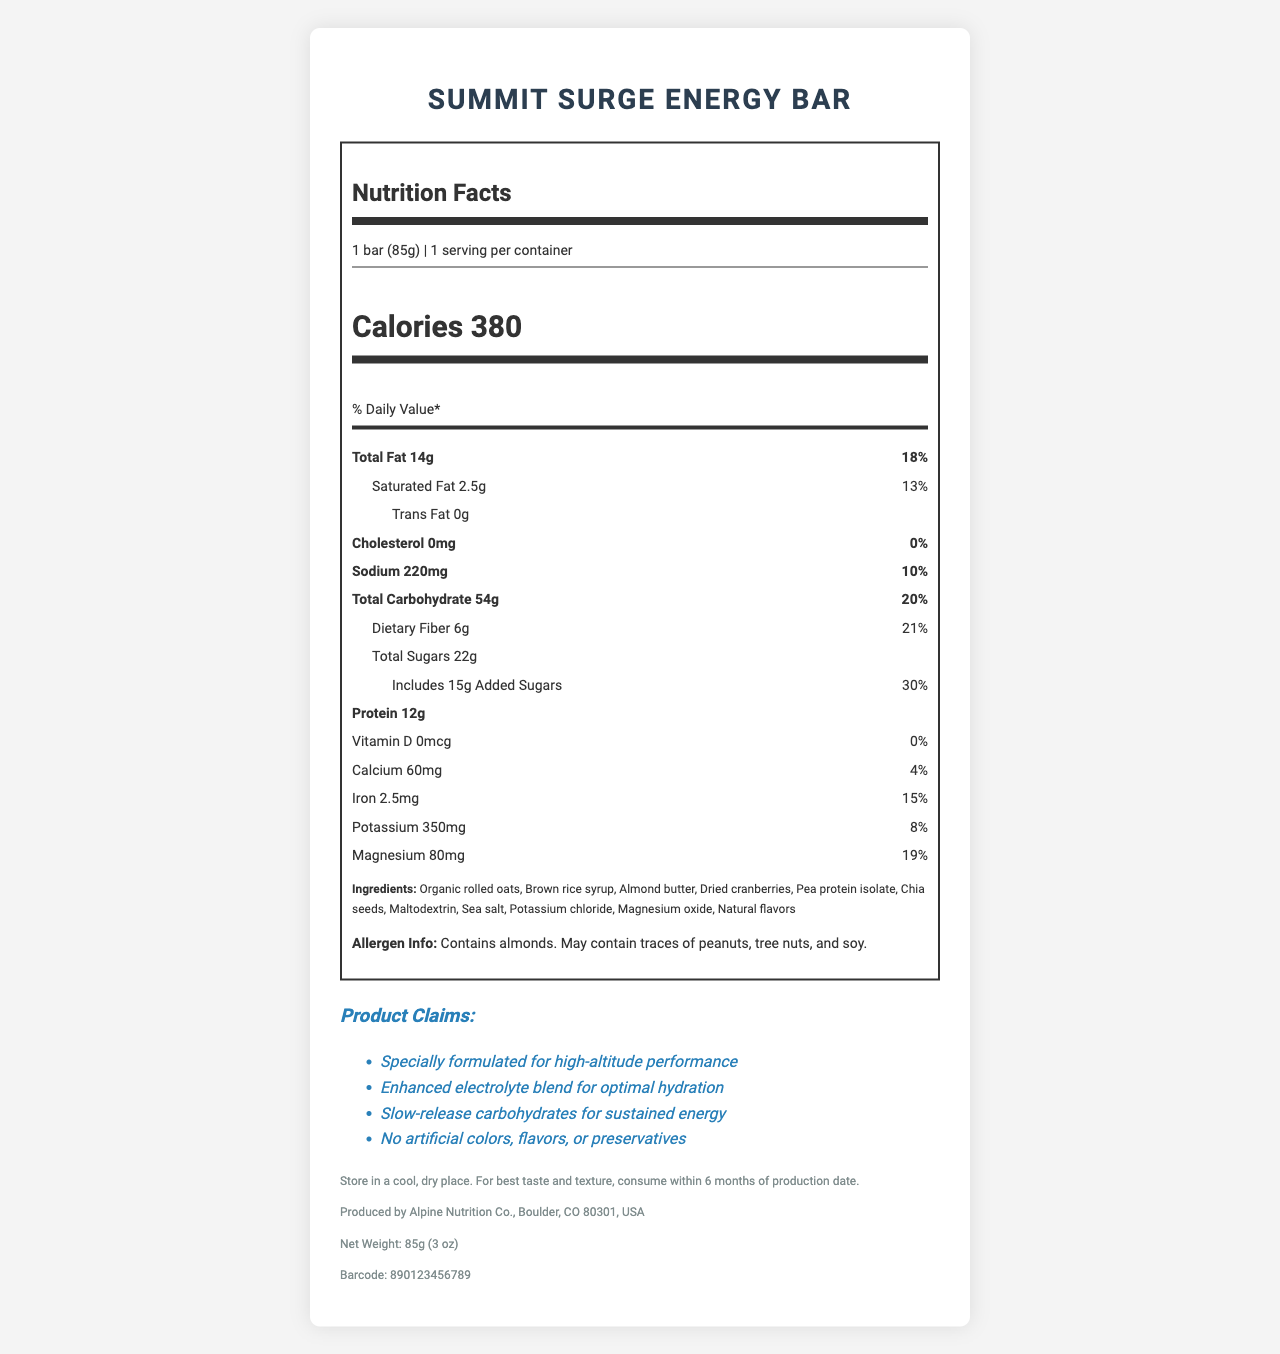What is the serving size of the Summit Surge Energy Bar? The serving size is stated explicitly as "1 bar (85g)" under the nutrition facts section.
Answer: 1 bar (85g) How many calories are in one serving of the Summit Surge Energy Bar? The document specifies "Calories 380" prominently under the nutrition facts.
Answer: 380 What percentage of the daily value of saturated fat does one bar provide? Under the saturated fat section, it lists "2.5g" and "13%".
Answer: 13% Which ingredient is listed first in the Summit Surge Energy Bar? The ingredients are listed in order of predominance, and organic rolled oats are the first ingredient mentioned.
Answer: Organic rolled oats How much added sugars does the Summit Surge Energy Bar contain? The document shows "Includes 15g Added Sugars" under the total sugars section.
Answer: 15g What are the total carbohydrates in one serving? A. 10g B. 20g C. 30g D. 54g The total carbohydrates are listed as "54g" with a daily value of 20%.
Answer: D. 54g Which of the following electrolytes are included in the Summit Surge Energy Bar? I. Sodium II. Magnesium III. Potassium IV. Calcium All listed electrolytes appear in the nutrition facts: sodium (220mg), magnesium (80mg), potassium (350mg), and calcium (60mg).
Answer: I, II, III, IV Does the Summit Surge Energy Bar contain any cholesterol? The document specifies "Cholesterol 0mg" with a daily value of "0%".
Answer: No Summarize the main nutritional benefits of the Summit Surge Energy Bar. The document highlights the nutritional composition, electrolyte content, and specific claim statements focusing on high-altitude performance and sustained energy.
Answer: The Summit Surge Energy Bar provides high carbohydrates (54g) and protein (12g), along with essential electrolytes like sodium, potassium, and magnesium. It's specially formulated for high-altitude performance, offering sustained energy and hydration without artificial additives. What is the net weight of the Summit Surge Energy Bar? The document mentions the net weight in the additional information section: "Net Weight: 85g (3 oz)".
Answer: 85g (3 oz) Who is the manufacturer of the Summit Surge Energy Bar? This information is provided in the additional info at the end of the document.
Answer: Alpine Nutrition Co., Boulder, CO 80301, USA Is the Summit Surge Energy Bar suitable for someone with a tree nut allergy? The allergen information specifies that the product contains almonds and may contain traces of tree nuts.
Answer: No How long is the recommended shelf life of the Summit Surge Energy Bar? The storage instructions indicate "consume within 6 months of production date."
Answer: 6 months from the production date Does the Summit Surge Energy Bar have any artificial colors, flavors, or preservatives? One of the claim statements declares "No artificial colors, flavors, or preservatives."
Answer: No What is the barcode number for the Summit Surge Energy Bar? The barcode number is provided at the end of the additional information section.
Answer: 890123456789 What is the main ingredient providing carbohydrates in the Summit Surge Energy Bar? The document lists multiple potential carb sources like organic rolled oats and brown rice syrup, but it doesn't specify which one is primary.
Answer: Cannot be determined 